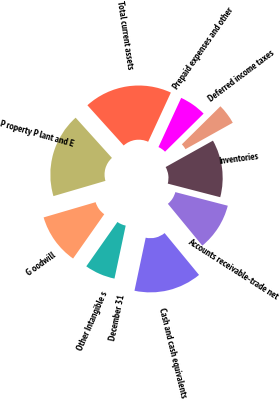Convert chart to OTSL. <chart><loc_0><loc_0><loc_500><loc_500><pie_chart><fcel>December 31<fcel>Cash and cash equivalents<fcel>Accounts receivable-trade net<fcel>Inventories<fcel>Deferred income taxes<fcel>Prepaid expenses and other<fcel>Total current assets<fcel>P roperty P lant and E<fcel>G oodwill<fcel>Other Intangible s<nl><fcel>0.0%<fcel>14.28%<fcel>10.0%<fcel>12.14%<fcel>4.29%<fcel>5.72%<fcel>18.57%<fcel>17.85%<fcel>10.71%<fcel>6.43%<nl></chart> 